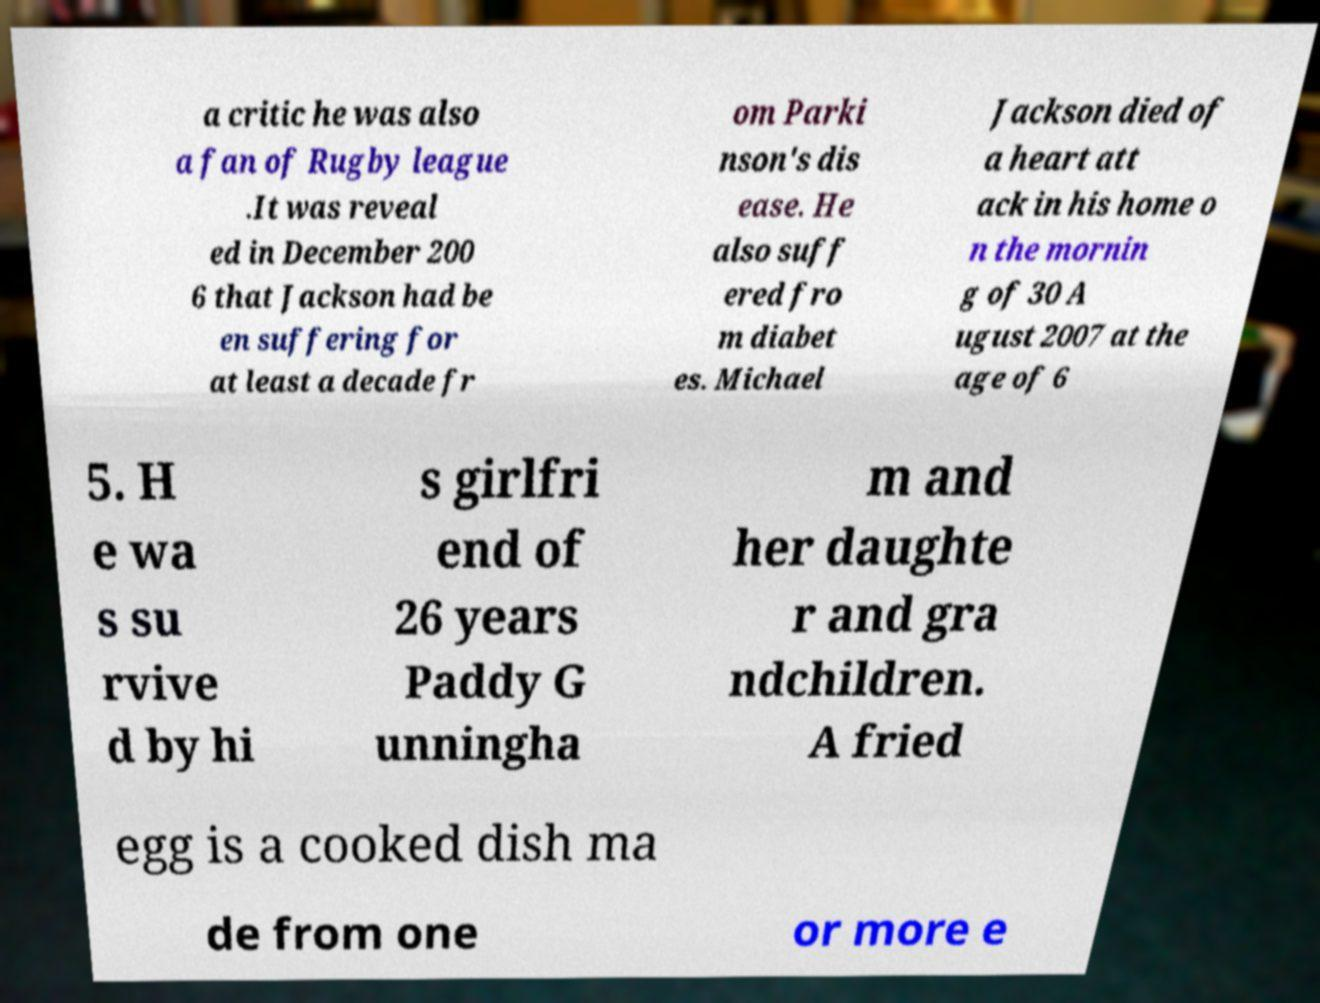Please identify and transcribe the text found in this image. a critic he was also a fan of Rugby league .It was reveal ed in December 200 6 that Jackson had be en suffering for at least a decade fr om Parki nson's dis ease. He also suff ered fro m diabet es. Michael Jackson died of a heart att ack in his home o n the mornin g of 30 A ugust 2007 at the age of 6 5. H e wa s su rvive d by hi s girlfri end of 26 years Paddy G unningha m and her daughte r and gra ndchildren. A fried egg is a cooked dish ma de from one or more e 